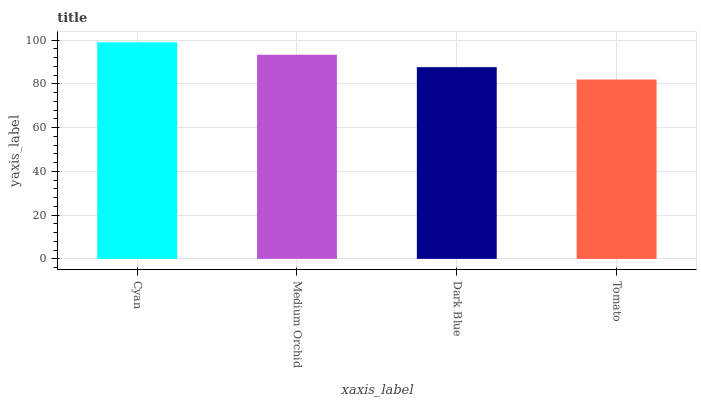Is Tomato the minimum?
Answer yes or no. Yes. Is Cyan the maximum?
Answer yes or no. Yes. Is Medium Orchid the minimum?
Answer yes or no. No. Is Medium Orchid the maximum?
Answer yes or no. No. Is Cyan greater than Medium Orchid?
Answer yes or no. Yes. Is Medium Orchid less than Cyan?
Answer yes or no. Yes. Is Medium Orchid greater than Cyan?
Answer yes or no. No. Is Cyan less than Medium Orchid?
Answer yes or no. No. Is Medium Orchid the high median?
Answer yes or no. Yes. Is Dark Blue the low median?
Answer yes or no. Yes. Is Tomato the high median?
Answer yes or no. No. Is Medium Orchid the low median?
Answer yes or no. No. 